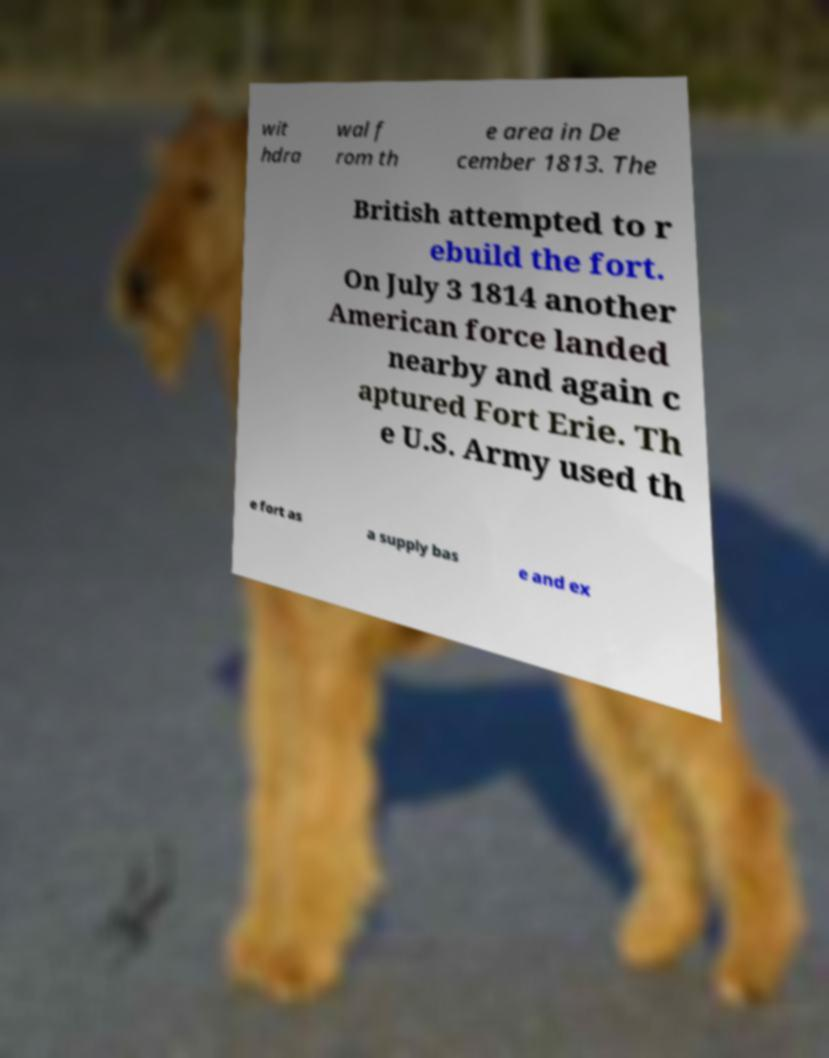Can you accurately transcribe the text from the provided image for me? wit hdra wal f rom th e area in De cember 1813. The British attempted to r ebuild the fort. On July 3 1814 another American force landed nearby and again c aptured Fort Erie. Th e U.S. Army used th e fort as a supply bas e and ex 